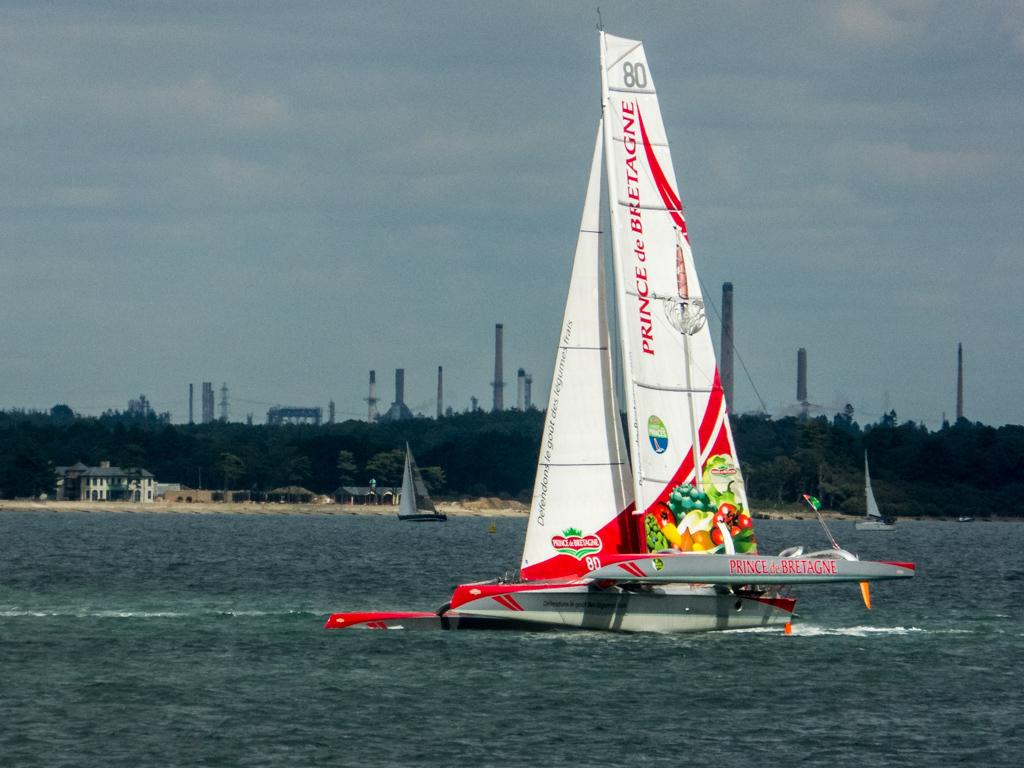What is on the water in the image? There are boats on the water in the image. What can be seen in the background of the image? There are trees, buildings, and towers in the background of the image. What is visible at the top of the image? The sky is visible at the top of the image. What type of tent can be seen in the image? There is no tent present in the image. What kind of food is being served on the boats in the image? There is no food visible in the image, as it only shows boats on the water. 